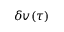Convert formula to latex. <formula><loc_0><loc_0><loc_500><loc_500>\delta v ( \tau )</formula> 